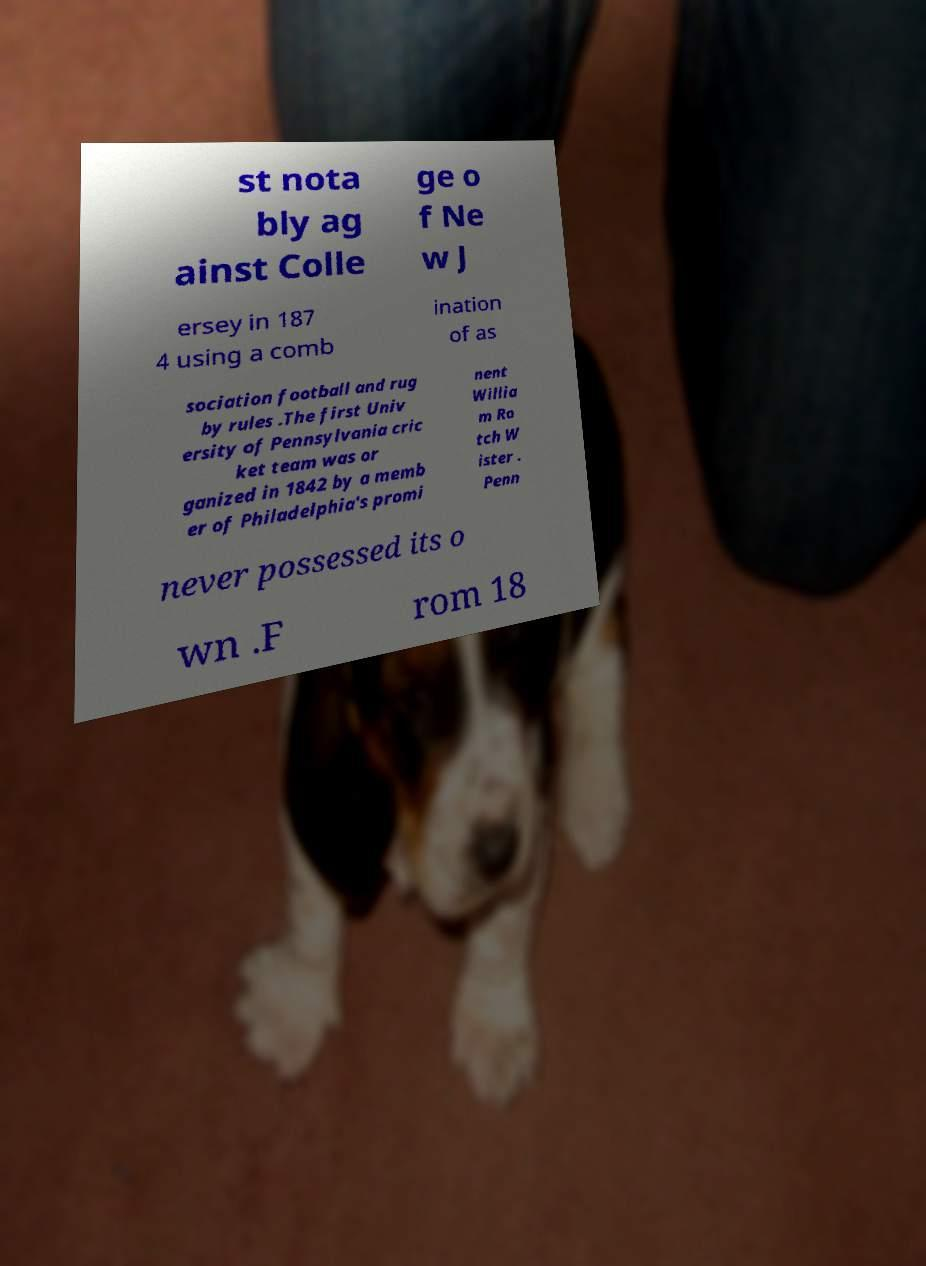Please identify and transcribe the text found in this image. st nota bly ag ainst Colle ge o f Ne w J ersey in 187 4 using a comb ination of as sociation football and rug by rules .The first Univ ersity of Pennsylvania cric ket team was or ganized in 1842 by a memb er of Philadelphia's promi nent Willia m Ro tch W ister . Penn never possessed its o wn .F rom 18 